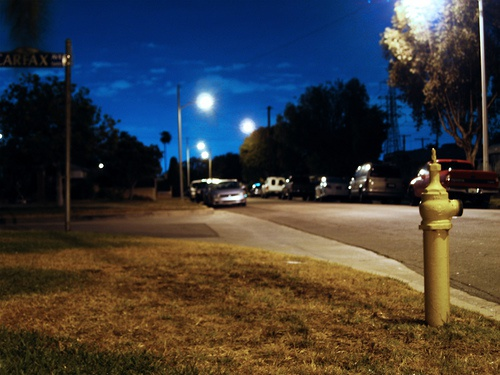Describe the objects in this image and their specific colors. I can see fire hydrant in black, olive, tan, and maroon tones, truck in black, maroon, and gray tones, truck in black, maroon, and brown tones, car in black, maroon, and gray tones, and car in black, gray, white, and darkgray tones in this image. 